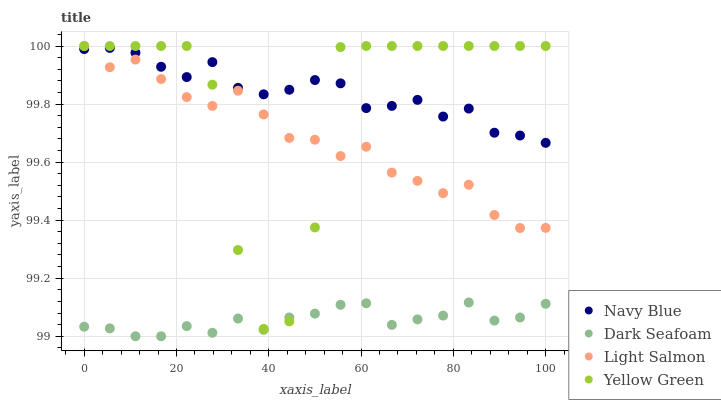Does Dark Seafoam have the minimum area under the curve?
Answer yes or no. Yes. Does Navy Blue have the maximum area under the curve?
Answer yes or no. Yes. Does Light Salmon have the minimum area under the curve?
Answer yes or no. No. Does Light Salmon have the maximum area under the curve?
Answer yes or no. No. Is Dark Seafoam the smoothest?
Answer yes or no. Yes. Is Yellow Green the roughest?
Answer yes or no. Yes. Is Light Salmon the smoothest?
Answer yes or no. No. Is Light Salmon the roughest?
Answer yes or no. No. Does Dark Seafoam have the lowest value?
Answer yes or no. Yes. Does Light Salmon have the lowest value?
Answer yes or no. No. Does Yellow Green have the highest value?
Answer yes or no. Yes. Does Dark Seafoam have the highest value?
Answer yes or no. No. Is Dark Seafoam less than Navy Blue?
Answer yes or no. Yes. Is Light Salmon greater than Dark Seafoam?
Answer yes or no. Yes. Does Yellow Green intersect Dark Seafoam?
Answer yes or no. Yes. Is Yellow Green less than Dark Seafoam?
Answer yes or no. No. Is Yellow Green greater than Dark Seafoam?
Answer yes or no. No. Does Dark Seafoam intersect Navy Blue?
Answer yes or no. No. 